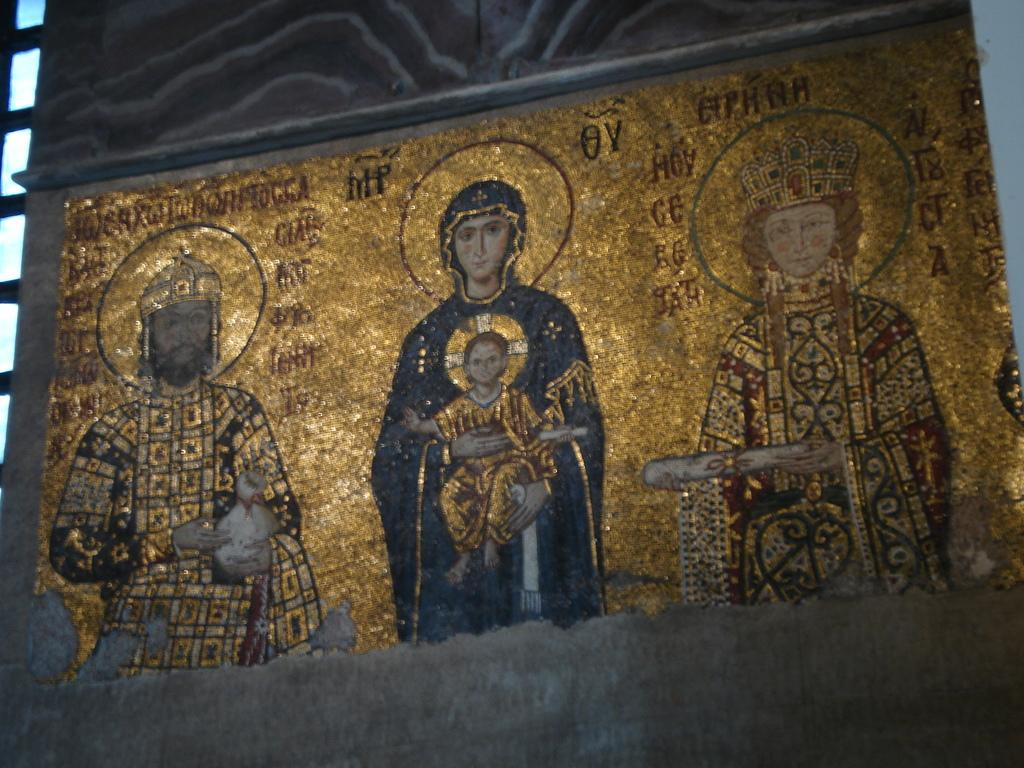What is on the wall in the image? There is a poster on the wall in the image. What can be seen in the poster? The poster contains images of people. Is there any text on the poster? Yes, there is text present on the poster. What type of pigs are depicted in the poster? There are no pigs present in the image or the poster. 